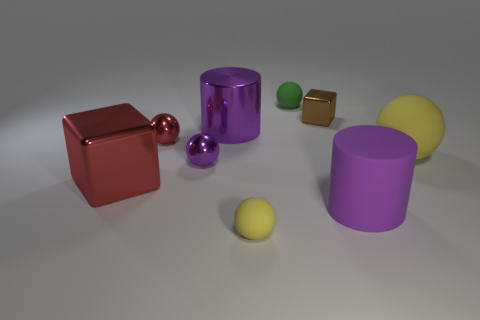Subtract all green spheres. How many spheres are left? 4 Subtract all tiny purple balls. How many balls are left? 4 Subtract all gray balls. Subtract all cyan cylinders. How many balls are left? 5 Add 1 small green spheres. How many objects exist? 10 Subtract all cylinders. How many objects are left? 7 Add 5 big yellow spheres. How many big yellow spheres are left? 6 Add 3 tiny purple metal spheres. How many tiny purple metal spheres exist? 4 Subtract 0 cyan cubes. How many objects are left? 9 Subtract all tiny brown rubber objects. Subtract all small rubber balls. How many objects are left? 7 